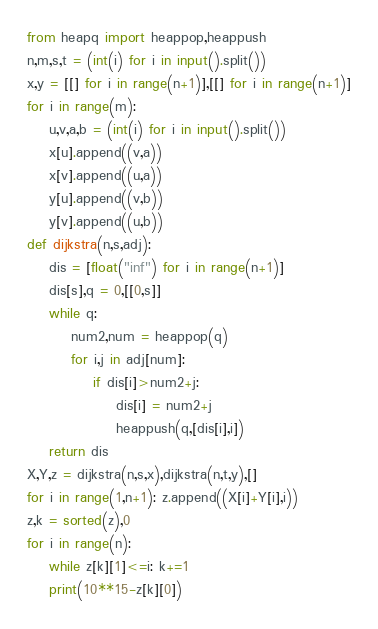<code> <loc_0><loc_0><loc_500><loc_500><_Python_>from heapq import heappop,heappush
n,m,s,t = (int(i) for i in input().split())
x,y = [[] for i in range(n+1)],[[] for i in range(n+1)]
for i in range(m):
    u,v,a,b = (int(i) for i in input().split())
    x[u].append((v,a))
    x[v].append((u,a))
    y[u].append((v,b))
    y[v].append((u,b))
def dijkstra(n,s,adj):
	dis = [float("inf") for i in range(n+1)]
	dis[s],q = 0,[[0,s]]
	while q:
		num2,num = heappop(q)
		for i,j in adj[num]:
			if dis[i]>num2+j:
				dis[i] = num2+j
				heappush(q,[dis[i],i])
	return dis
X,Y,z = dijkstra(n,s,x),dijkstra(n,t,y),[]
for i in range(1,n+1): z.append((X[i]+Y[i],i))
z,k = sorted(z),0
for i in range(n):
    while z[k][1]<=i: k+=1
    print(10**15-z[k][0])</code> 